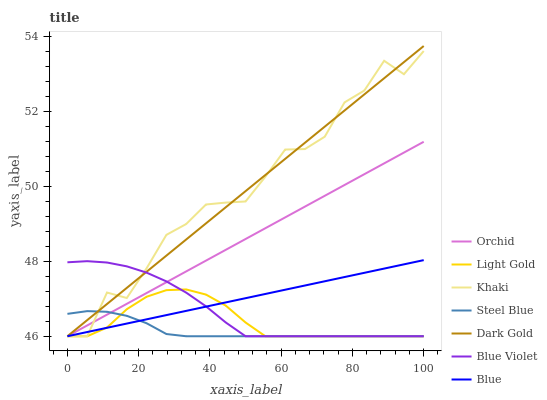Does Steel Blue have the minimum area under the curve?
Answer yes or no. Yes. Does Khaki have the maximum area under the curve?
Answer yes or no. Yes. Does Dark Gold have the minimum area under the curve?
Answer yes or no. No. Does Dark Gold have the maximum area under the curve?
Answer yes or no. No. Is Orchid the smoothest?
Answer yes or no. Yes. Is Khaki the roughest?
Answer yes or no. Yes. Is Dark Gold the smoothest?
Answer yes or no. No. Is Dark Gold the roughest?
Answer yes or no. No. Does Dark Gold have the highest value?
Answer yes or no. Yes. Does Khaki have the highest value?
Answer yes or no. No. Does Blue intersect Dark Gold?
Answer yes or no. Yes. Is Blue less than Dark Gold?
Answer yes or no. No. Is Blue greater than Dark Gold?
Answer yes or no. No. 